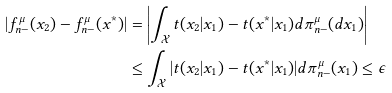<formula> <loc_0><loc_0><loc_500><loc_500>| f _ { n - } ^ { \mu } ( x _ { 2 } ) - f _ { n - } ^ { \mu } ( x ^ { * } ) | & = \left | \int _ { \mathcal { X } } t ( x _ { 2 } | x _ { 1 } ) - t ( x ^ { * } | x _ { 1 } ) d \pi _ { n - } ^ { \mu } ( d x _ { 1 } ) \right | \\ & \leq \int _ { \mathcal { X } } | t ( x _ { 2 } | x _ { 1 } ) - t ( x ^ { * } | x _ { 1 } ) | d \pi _ { n - } ^ { \mu } ( x _ { 1 } ) \leq \epsilon</formula> 